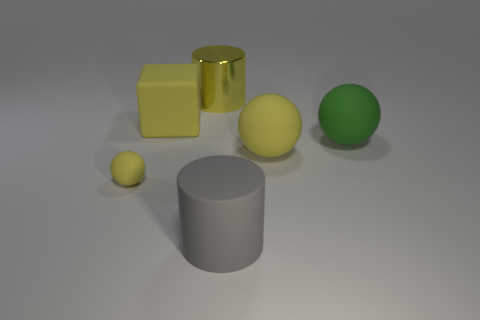Add 3 cyan rubber cubes. How many objects exist? 9 Subtract all cylinders. How many objects are left? 4 Subtract 0 purple cubes. How many objects are left? 6 Subtract all tiny yellow shiny cubes. Subtract all big yellow rubber spheres. How many objects are left? 5 Add 3 yellow metal things. How many yellow metal things are left? 4 Add 5 red balls. How many red balls exist? 5 